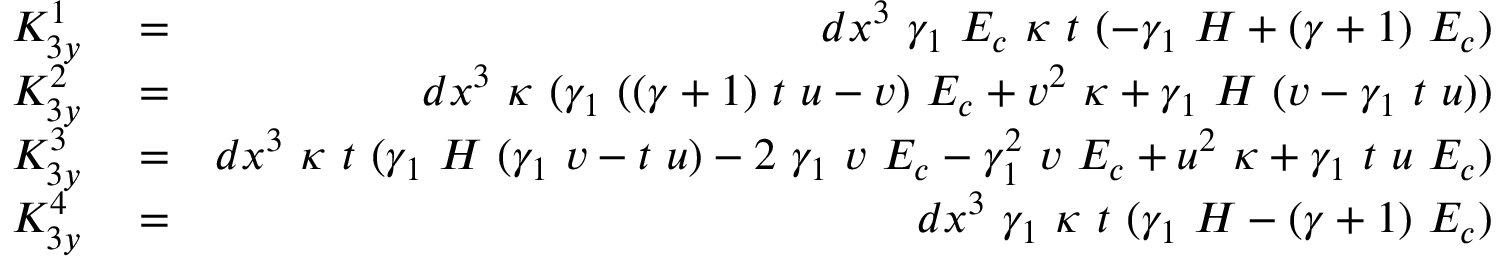<formula> <loc_0><loc_0><loc_500><loc_500>\begin{array} { r l r } { K _ { 3 y } ^ { 1 } } & = } & { d x ^ { 3 } \gamma _ { 1 } E _ { c } \kappa t ( - \gamma _ { 1 } H + ( \gamma + 1 ) E _ { c } ) } \\ { K _ { 3 y } ^ { 2 } } & = } & { d x ^ { 3 } \kappa ( \gamma _ { 1 } ( ( \gamma + 1 ) t u - v ) E _ { c } + v ^ { 2 } \kappa + \gamma _ { 1 } H ( v - \gamma _ { 1 } t u ) ) } \\ { K _ { 3 y } ^ { 3 } } & = } & { d x ^ { 3 } \kappa t ( \gamma _ { 1 } H ( \gamma _ { 1 } v - t u ) - 2 \gamma _ { 1 } v E _ { c } - \gamma _ { 1 } ^ { 2 } v E _ { c } + u ^ { 2 } \kappa + \gamma _ { 1 } t u E _ { c } ) } \\ { K _ { 3 y } ^ { 4 } } & = } & { d x ^ { 3 } \gamma _ { 1 } \kappa t ( \gamma _ { 1 } H - ( \gamma + 1 ) E _ { c } ) } \end{array}</formula> 